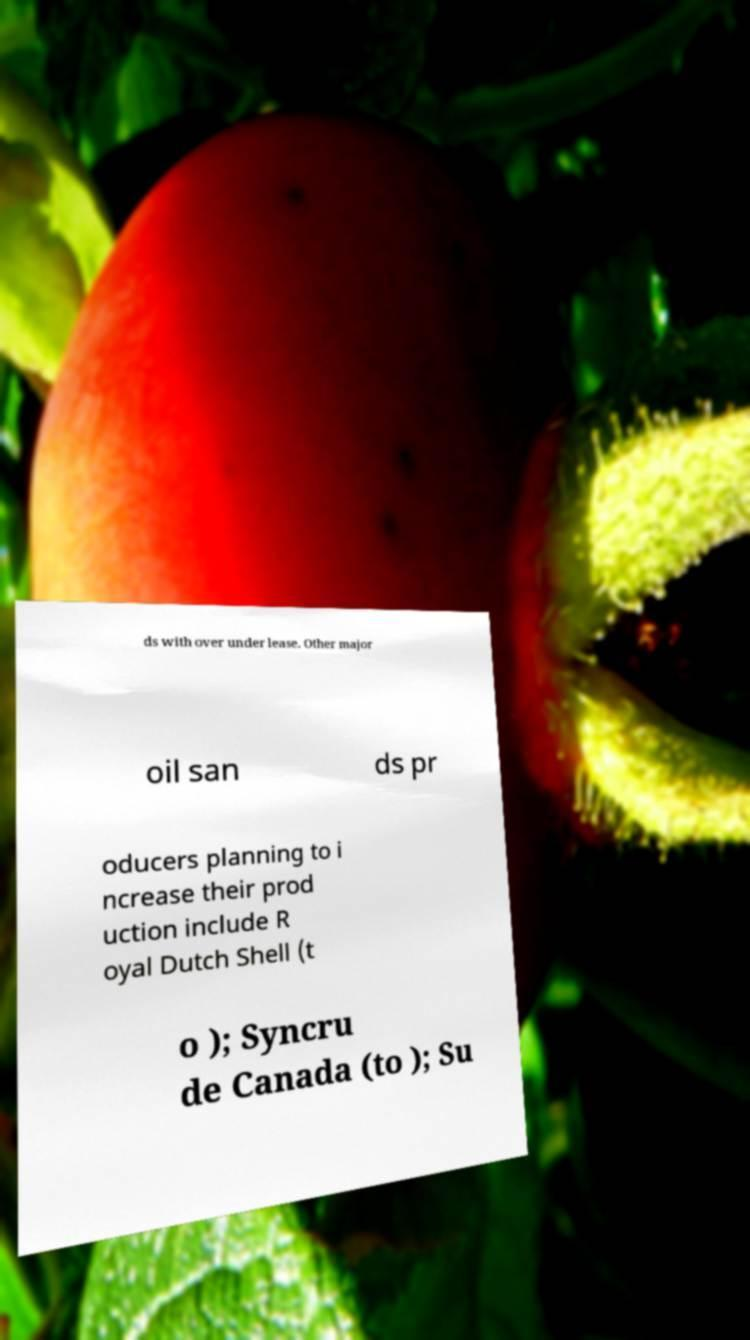Could you extract and type out the text from this image? ds with over under lease. Other major oil san ds pr oducers planning to i ncrease their prod uction include R oyal Dutch Shell (t o ); Syncru de Canada (to ); Su 